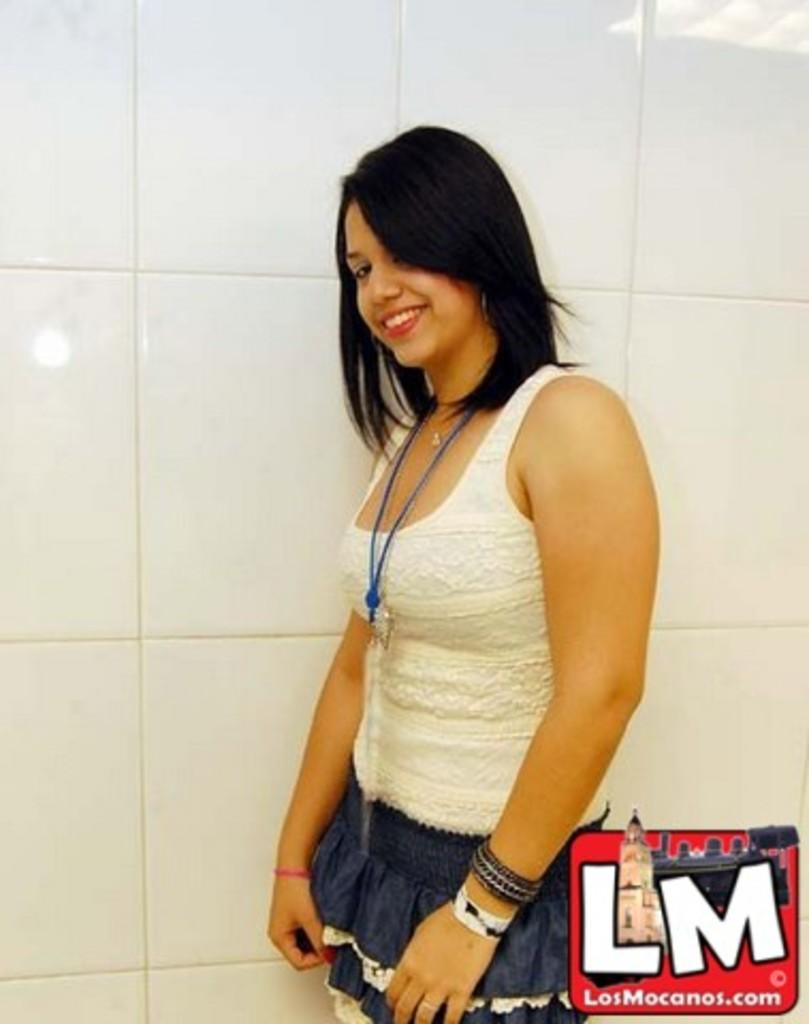What is the main subject of the image? There is a person in the image. What is the person doing in the image? The person is smiling. What is the person wearing in the image? The person is wearing a white and blue color dress. What color is the background of the image? The background of the image is white. What type of shoe is the person wearing in the image? There is no shoe visible in the image; the person's feet are not shown. How many balloons are present in the image? There are no balloons present in the image. 